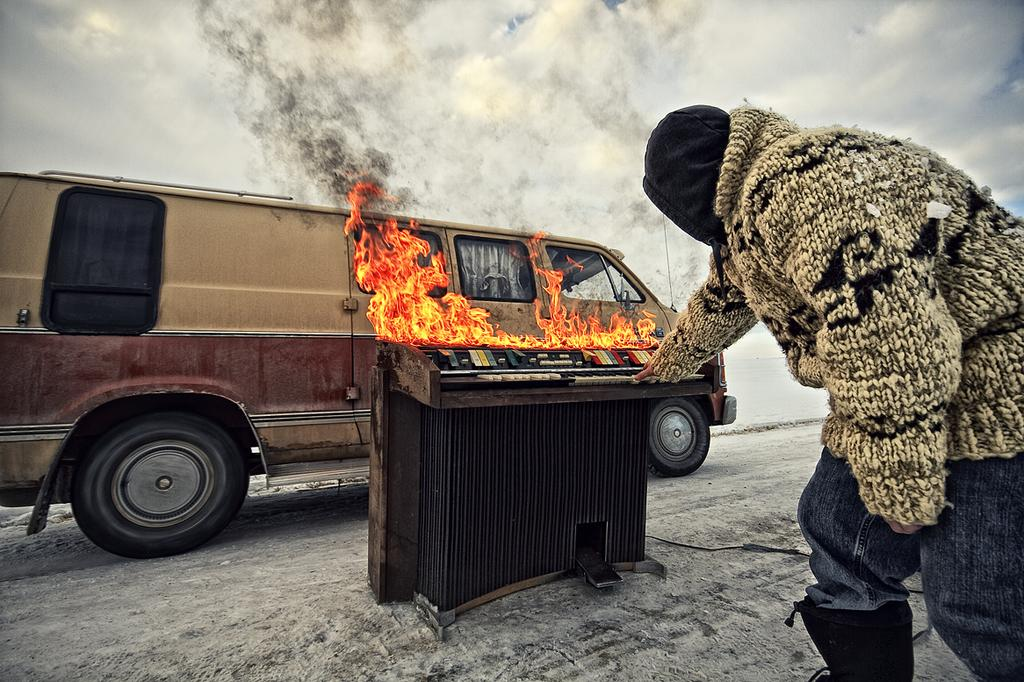What type of vehicle is in the image? There is a van in the image. What is happening to the object in the image? There is an object burning in the image. Can you describe the person in the image? There is a person standing on the right side of the image. What is visible at the top of the image? The sky is visible at the top of the image. Where are the ants in the image? There are no ants present in the image. What type of building is visible in the image? There is no building visible in the image. 